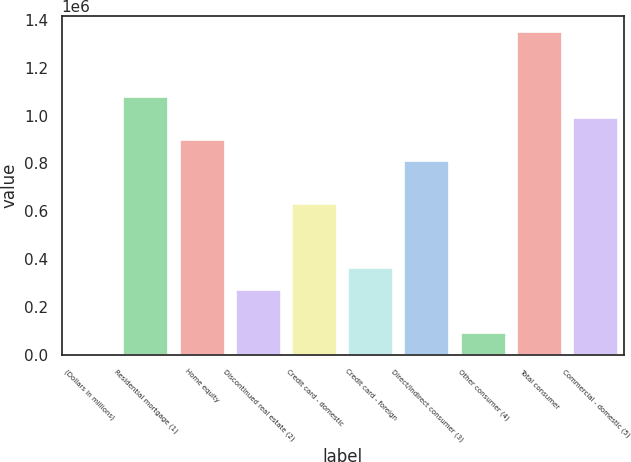Convert chart. <chart><loc_0><loc_0><loc_500><loc_500><bar_chart><fcel>(Dollars in millions)<fcel>Residential mortgage (1)<fcel>Home equity<fcel>Discontinued real estate (2)<fcel>Credit card - domestic<fcel>Credit card - foreign<fcel>Direct/Indirect consumer (3)<fcel>Other consumer (4)<fcel>Total consumer<fcel>Commercial - domestic (5)<nl><fcel>2009<fcel>1.07975e+06<fcel>900128<fcel>271445<fcel>630692<fcel>361257<fcel>810316<fcel>91820.9<fcel>1.34919e+06<fcel>989940<nl></chart> 